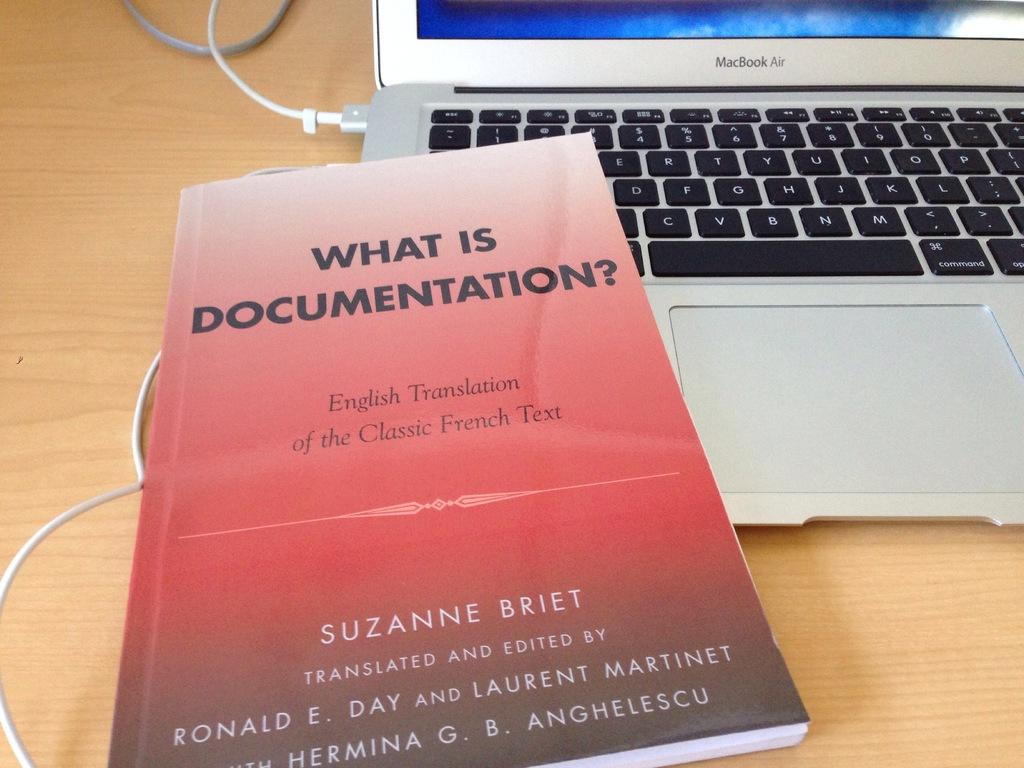<image>
Provide a brief description of the given image. An English translation of What is Documentation by Suzanne Briet. 